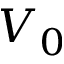Convert formula to latex. <formula><loc_0><loc_0><loc_500><loc_500>V _ { 0 }</formula> 